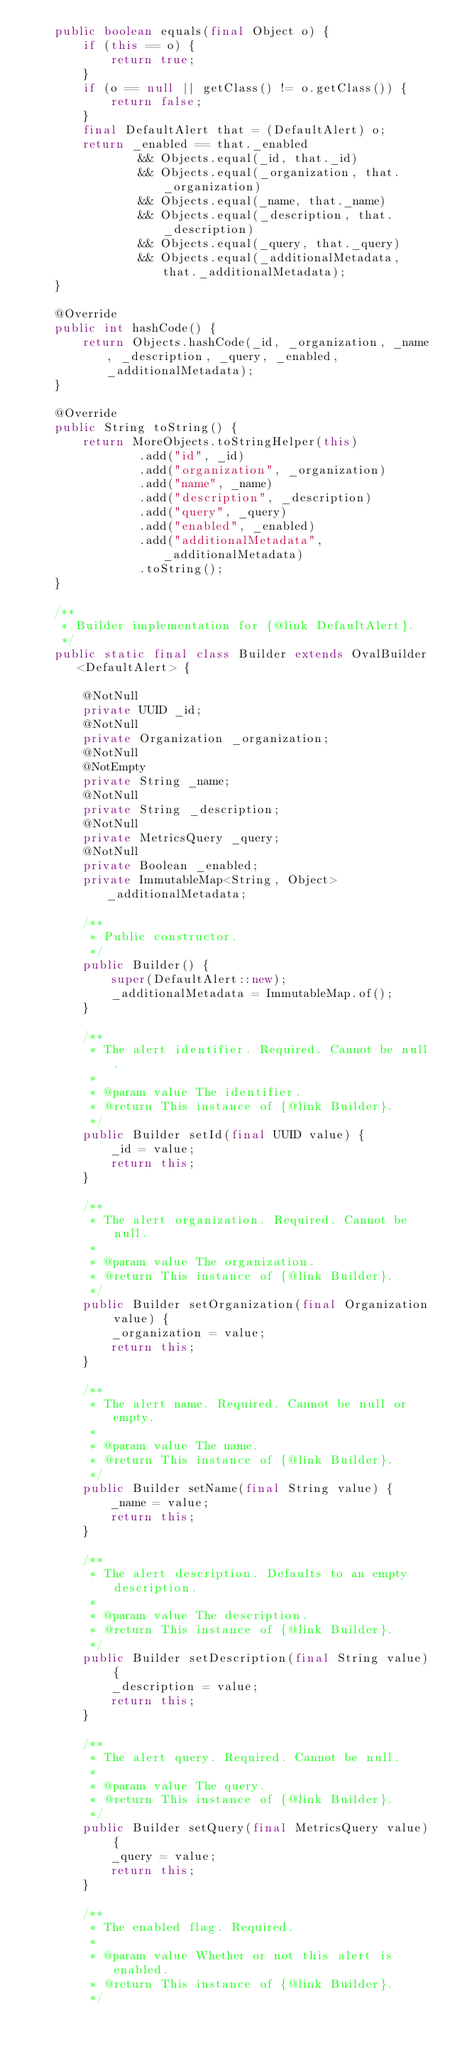Convert code to text. <code><loc_0><loc_0><loc_500><loc_500><_Java_>    public boolean equals(final Object o) {
        if (this == o) {
            return true;
        }
        if (o == null || getClass() != o.getClass()) {
            return false;
        }
        final DefaultAlert that = (DefaultAlert) o;
        return _enabled == that._enabled
                && Objects.equal(_id, that._id)
                && Objects.equal(_organization, that._organization)
                && Objects.equal(_name, that._name)
                && Objects.equal(_description, that._description)
                && Objects.equal(_query, that._query)
                && Objects.equal(_additionalMetadata, that._additionalMetadata);
    }

    @Override
    public int hashCode() {
        return Objects.hashCode(_id, _organization, _name, _description, _query, _enabled, _additionalMetadata);
    }

    @Override
    public String toString() {
        return MoreObjects.toStringHelper(this)
                .add("id", _id)
                .add("organization", _organization)
                .add("name", _name)
                .add("description", _description)
                .add("query", _query)
                .add("enabled", _enabled)
                .add("additionalMetadata", _additionalMetadata)
                .toString();
    }

    /**
     * Builder implementation for {@link DefaultAlert}.
     */
    public static final class Builder extends OvalBuilder<DefaultAlert> {

        @NotNull
        private UUID _id;
        @NotNull
        private Organization _organization;
        @NotNull
        @NotEmpty
        private String _name;
        @NotNull
        private String _description;
        @NotNull
        private MetricsQuery _query;
        @NotNull
        private Boolean _enabled;
        private ImmutableMap<String, Object> _additionalMetadata;

        /**
         * Public constructor.
         */
        public Builder() {
            super(DefaultAlert::new);
            _additionalMetadata = ImmutableMap.of();
        }

        /**
         * The alert identifier. Required. Cannot be null.
         *
         * @param value The identifier.
         * @return This instance of {@link Builder}.
         */
        public Builder setId(final UUID value) {
            _id = value;
            return this;
        }

        /**
         * The alert organization. Required. Cannot be null.
         *
         * @param value The organization.
         * @return This instance of {@link Builder}.
         */
        public Builder setOrganization(final Organization value) {
            _organization = value;
            return this;
        }

        /**
         * The alert name. Required. Cannot be null or empty.
         *
         * @param value The name.
         * @return This instance of {@link Builder}.
         */
        public Builder setName(final String value) {
            _name = value;
            return this;
        }

        /**
         * The alert description. Defaults to an empty description.
         *
         * @param value The description.
         * @return This instance of {@link Builder}.
         */
        public Builder setDescription(final String value) {
            _description = value;
            return this;
        }

        /**
         * The alert query. Required. Cannot be null.
         *
         * @param value The query.
         * @return This instance of {@link Builder}.
         */
        public Builder setQuery(final MetricsQuery value) {
            _query = value;
            return this;
        }

        /**
         * The enabled flag. Required.
         *
         * @param value Whether or not this alert is enabled.
         * @return This instance of {@link Builder}.
         */</code> 